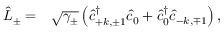Convert formula to latex. <formula><loc_0><loc_0><loc_500><loc_500>\begin{array} { r l } { \hat { L } _ { \pm } = } & \sqrt { \gamma _ { \pm } } \left ( \hat { c } _ { + k , \pm 1 } ^ { \dagger } \hat { c } _ { 0 } + \hat { c } _ { 0 } ^ { \dagger } \hat { c } _ { - k , \mp 1 } \right ) , } \end{array}</formula> 